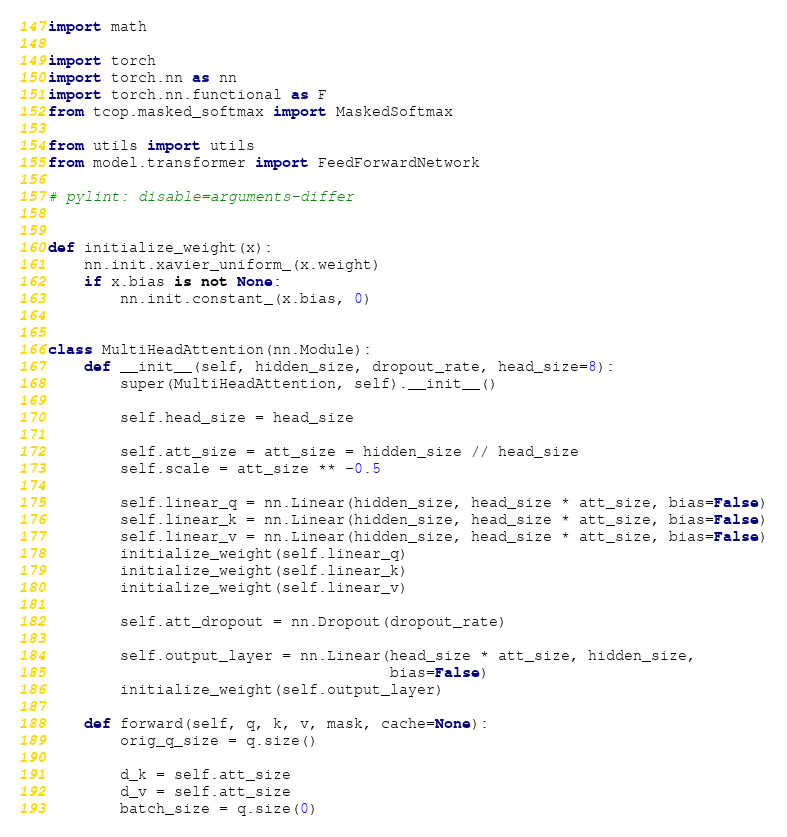<code> <loc_0><loc_0><loc_500><loc_500><_Python_>import math

import torch
import torch.nn as nn
import torch.nn.functional as F
from tcop.masked_softmax import MaskedSoftmax

from utils import utils
from model.transformer import FeedForwardNetwork

# pylint: disable=arguments-differ


def initialize_weight(x):
    nn.init.xavier_uniform_(x.weight)
    if x.bias is not None:
        nn.init.constant_(x.bias, 0)


class MultiHeadAttention(nn.Module):
    def __init__(self, hidden_size, dropout_rate, head_size=8):
        super(MultiHeadAttention, self).__init__()

        self.head_size = head_size

        self.att_size = att_size = hidden_size // head_size
        self.scale = att_size ** -0.5

        self.linear_q = nn.Linear(hidden_size, head_size * att_size, bias=False)
        self.linear_k = nn.Linear(hidden_size, head_size * att_size, bias=False)
        self.linear_v = nn.Linear(hidden_size, head_size * att_size, bias=False)
        initialize_weight(self.linear_q)
        initialize_weight(self.linear_k)
        initialize_weight(self.linear_v)

        self.att_dropout = nn.Dropout(dropout_rate)

        self.output_layer = nn.Linear(head_size * att_size, hidden_size,
                                      bias=False)
        initialize_weight(self.output_layer)

    def forward(self, q, k, v, mask, cache=None):
        orig_q_size = q.size()

        d_k = self.att_size
        d_v = self.att_size
        batch_size = q.size(0)
</code> 